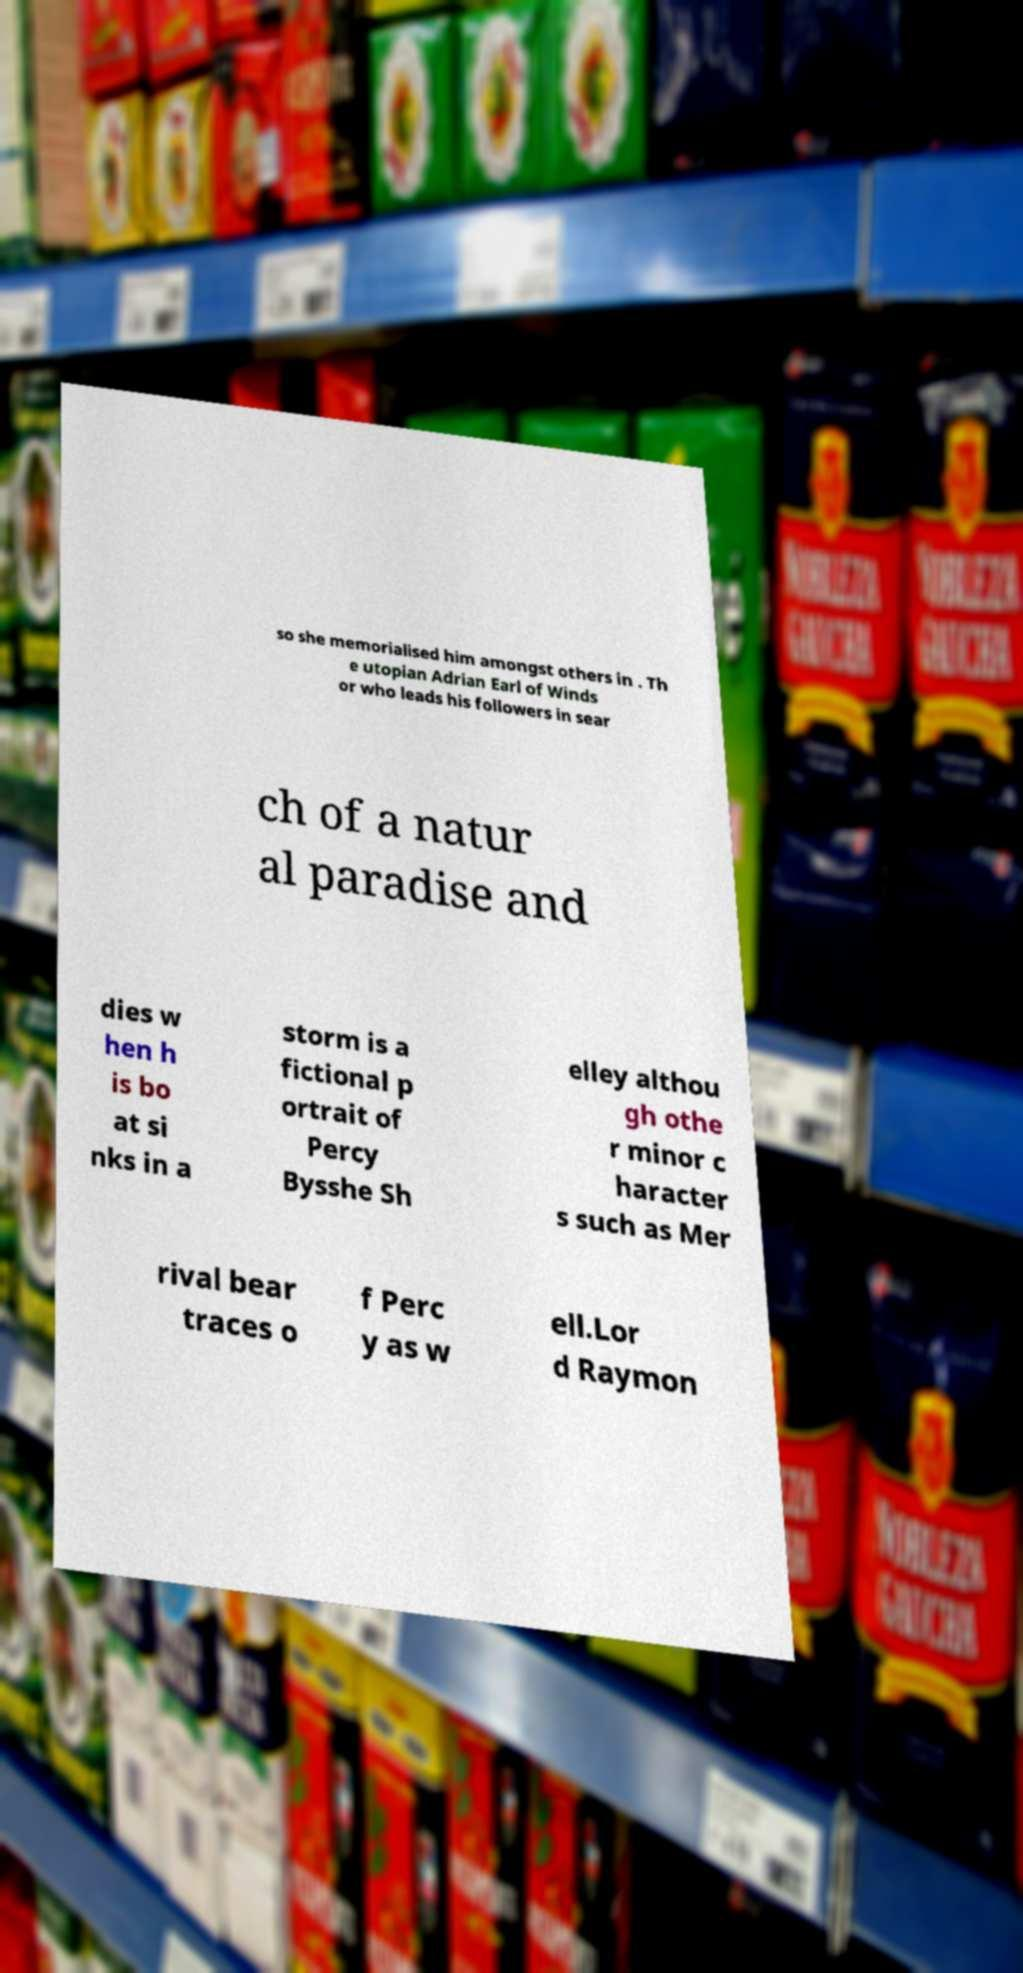Can you accurately transcribe the text from the provided image for me? so she memorialised him amongst others in . Th e utopian Adrian Earl of Winds or who leads his followers in sear ch of a natur al paradise and dies w hen h is bo at si nks in a storm is a fictional p ortrait of Percy Bysshe Sh elley althou gh othe r minor c haracter s such as Mer rival bear traces o f Perc y as w ell.Lor d Raymon 